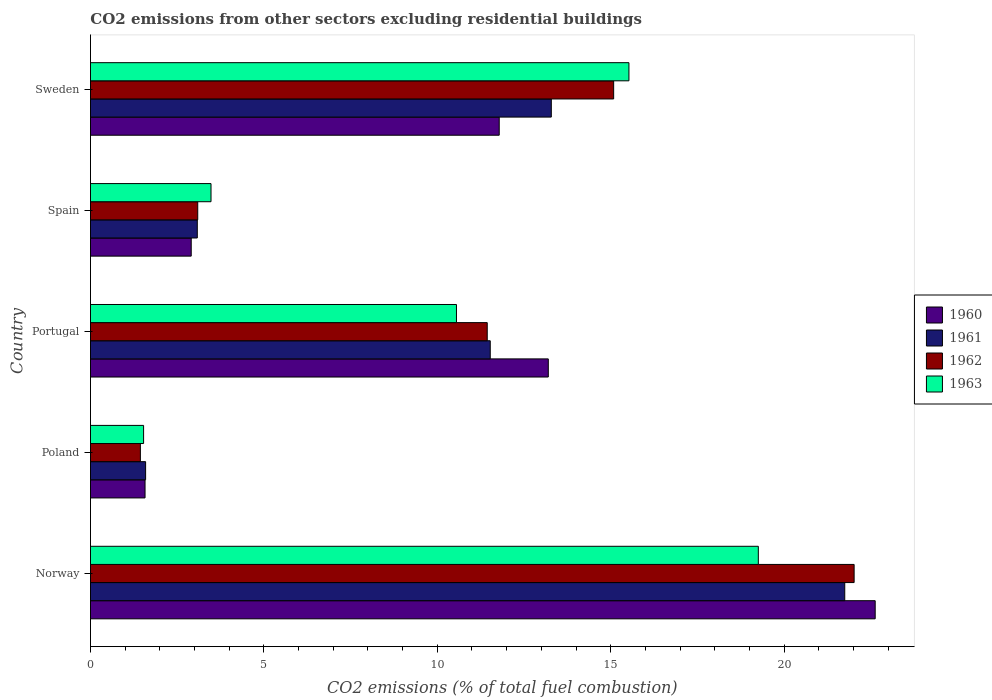How many different coloured bars are there?
Ensure brevity in your answer.  4. Are the number of bars per tick equal to the number of legend labels?
Provide a short and direct response. Yes. How many bars are there on the 5th tick from the top?
Give a very brief answer. 4. What is the label of the 2nd group of bars from the top?
Your answer should be compact. Spain. In how many cases, is the number of bars for a given country not equal to the number of legend labels?
Give a very brief answer. 0. What is the total CO2 emitted in 1962 in Poland?
Your answer should be compact. 1.44. Across all countries, what is the maximum total CO2 emitted in 1963?
Ensure brevity in your answer.  19.26. Across all countries, what is the minimum total CO2 emitted in 1963?
Provide a short and direct response. 1.53. What is the total total CO2 emitted in 1962 in the graph?
Give a very brief answer. 53.08. What is the difference between the total CO2 emitted in 1962 in Spain and that in Sweden?
Give a very brief answer. -11.99. What is the difference between the total CO2 emitted in 1962 in Poland and the total CO2 emitted in 1960 in Spain?
Keep it short and to the point. -1.47. What is the average total CO2 emitted in 1962 per country?
Your response must be concise. 10.62. What is the difference between the total CO2 emitted in 1961 and total CO2 emitted in 1963 in Sweden?
Offer a terse response. -2.24. In how many countries, is the total CO2 emitted in 1960 greater than 7 ?
Give a very brief answer. 3. What is the ratio of the total CO2 emitted in 1960 in Poland to that in Sweden?
Make the answer very short. 0.13. What is the difference between the highest and the second highest total CO2 emitted in 1960?
Provide a succinct answer. 9.43. What is the difference between the highest and the lowest total CO2 emitted in 1961?
Keep it short and to the point. 20.16. In how many countries, is the total CO2 emitted in 1963 greater than the average total CO2 emitted in 1963 taken over all countries?
Ensure brevity in your answer.  3. What does the 2nd bar from the top in Poland represents?
Give a very brief answer. 1962. What does the 2nd bar from the bottom in Norway represents?
Keep it short and to the point. 1961. Is it the case that in every country, the sum of the total CO2 emitted in 1963 and total CO2 emitted in 1960 is greater than the total CO2 emitted in 1962?
Provide a short and direct response. Yes. Are all the bars in the graph horizontal?
Make the answer very short. Yes. What is the difference between two consecutive major ticks on the X-axis?
Offer a very short reply. 5. Does the graph contain grids?
Give a very brief answer. No. How are the legend labels stacked?
Your answer should be compact. Vertical. What is the title of the graph?
Offer a very short reply. CO2 emissions from other sectors excluding residential buildings. Does "1992" appear as one of the legend labels in the graph?
Offer a very short reply. No. What is the label or title of the X-axis?
Offer a terse response. CO2 emissions (% of total fuel combustion). What is the label or title of the Y-axis?
Your response must be concise. Country. What is the CO2 emissions (% of total fuel combustion) in 1960 in Norway?
Offer a terse response. 22.63. What is the CO2 emissions (% of total fuel combustion) in 1961 in Norway?
Make the answer very short. 21.75. What is the CO2 emissions (% of total fuel combustion) in 1962 in Norway?
Provide a short and direct response. 22.02. What is the CO2 emissions (% of total fuel combustion) in 1963 in Norway?
Keep it short and to the point. 19.26. What is the CO2 emissions (% of total fuel combustion) of 1960 in Poland?
Provide a short and direct response. 1.57. What is the CO2 emissions (% of total fuel combustion) of 1961 in Poland?
Make the answer very short. 1.59. What is the CO2 emissions (% of total fuel combustion) in 1962 in Poland?
Provide a succinct answer. 1.44. What is the CO2 emissions (% of total fuel combustion) in 1963 in Poland?
Keep it short and to the point. 1.53. What is the CO2 emissions (% of total fuel combustion) in 1960 in Portugal?
Offer a very short reply. 13.2. What is the CO2 emissions (% of total fuel combustion) in 1961 in Portugal?
Your response must be concise. 11.53. What is the CO2 emissions (% of total fuel combustion) of 1962 in Portugal?
Offer a terse response. 11.44. What is the CO2 emissions (% of total fuel combustion) of 1963 in Portugal?
Give a very brief answer. 10.55. What is the CO2 emissions (% of total fuel combustion) of 1960 in Spain?
Keep it short and to the point. 2.91. What is the CO2 emissions (% of total fuel combustion) of 1961 in Spain?
Provide a short and direct response. 3.08. What is the CO2 emissions (% of total fuel combustion) of 1962 in Spain?
Your answer should be compact. 3.09. What is the CO2 emissions (% of total fuel combustion) of 1963 in Spain?
Give a very brief answer. 3.48. What is the CO2 emissions (% of total fuel combustion) of 1960 in Sweden?
Offer a very short reply. 11.79. What is the CO2 emissions (% of total fuel combustion) of 1961 in Sweden?
Make the answer very short. 13.29. What is the CO2 emissions (% of total fuel combustion) in 1962 in Sweden?
Make the answer very short. 15.09. What is the CO2 emissions (% of total fuel combustion) of 1963 in Sweden?
Provide a succinct answer. 15.53. Across all countries, what is the maximum CO2 emissions (% of total fuel combustion) in 1960?
Provide a succinct answer. 22.63. Across all countries, what is the maximum CO2 emissions (% of total fuel combustion) in 1961?
Provide a short and direct response. 21.75. Across all countries, what is the maximum CO2 emissions (% of total fuel combustion) of 1962?
Your answer should be very brief. 22.02. Across all countries, what is the maximum CO2 emissions (% of total fuel combustion) of 1963?
Provide a succinct answer. 19.26. Across all countries, what is the minimum CO2 emissions (% of total fuel combustion) in 1960?
Your response must be concise. 1.57. Across all countries, what is the minimum CO2 emissions (% of total fuel combustion) of 1961?
Keep it short and to the point. 1.59. Across all countries, what is the minimum CO2 emissions (% of total fuel combustion) in 1962?
Ensure brevity in your answer.  1.44. Across all countries, what is the minimum CO2 emissions (% of total fuel combustion) of 1963?
Give a very brief answer. 1.53. What is the total CO2 emissions (% of total fuel combustion) in 1960 in the graph?
Keep it short and to the point. 52.09. What is the total CO2 emissions (% of total fuel combustion) of 1961 in the graph?
Your response must be concise. 51.24. What is the total CO2 emissions (% of total fuel combustion) of 1962 in the graph?
Provide a succinct answer. 53.08. What is the total CO2 emissions (% of total fuel combustion) in 1963 in the graph?
Keep it short and to the point. 50.34. What is the difference between the CO2 emissions (% of total fuel combustion) in 1960 in Norway and that in Poland?
Offer a terse response. 21.05. What is the difference between the CO2 emissions (% of total fuel combustion) of 1961 in Norway and that in Poland?
Offer a very short reply. 20.16. What is the difference between the CO2 emissions (% of total fuel combustion) of 1962 in Norway and that in Poland?
Provide a short and direct response. 20.58. What is the difference between the CO2 emissions (% of total fuel combustion) in 1963 in Norway and that in Poland?
Make the answer very short. 17.73. What is the difference between the CO2 emissions (% of total fuel combustion) of 1960 in Norway and that in Portugal?
Provide a short and direct response. 9.43. What is the difference between the CO2 emissions (% of total fuel combustion) in 1961 in Norway and that in Portugal?
Provide a succinct answer. 10.22. What is the difference between the CO2 emissions (% of total fuel combustion) of 1962 in Norway and that in Portugal?
Offer a very short reply. 10.58. What is the difference between the CO2 emissions (% of total fuel combustion) in 1963 in Norway and that in Portugal?
Ensure brevity in your answer.  8.7. What is the difference between the CO2 emissions (% of total fuel combustion) of 1960 in Norway and that in Spain?
Keep it short and to the point. 19.72. What is the difference between the CO2 emissions (% of total fuel combustion) in 1961 in Norway and that in Spain?
Ensure brevity in your answer.  18.67. What is the difference between the CO2 emissions (% of total fuel combustion) of 1962 in Norway and that in Spain?
Ensure brevity in your answer.  18.93. What is the difference between the CO2 emissions (% of total fuel combustion) of 1963 in Norway and that in Spain?
Offer a very short reply. 15.78. What is the difference between the CO2 emissions (% of total fuel combustion) in 1960 in Norway and that in Sweden?
Your answer should be very brief. 10.84. What is the difference between the CO2 emissions (% of total fuel combustion) in 1961 in Norway and that in Sweden?
Make the answer very short. 8.46. What is the difference between the CO2 emissions (% of total fuel combustion) in 1962 in Norway and that in Sweden?
Ensure brevity in your answer.  6.93. What is the difference between the CO2 emissions (% of total fuel combustion) in 1963 in Norway and that in Sweden?
Provide a succinct answer. 3.73. What is the difference between the CO2 emissions (% of total fuel combustion) in 1960 in Poland and that in Portugal?
Offer a very short reply. -11.63. What is the difference between the CO2 emissions (% of total fuel combustion) in 1961 in Poland and that in Portugal?
Provide a succinct answer. -9.94. What is the difference between the CO2 emissions (% of total fuel combustion) of 1962 in Poland and that in Portugal?
Your answer should be very brief. -10. What is the difference between the CO2 emissions (% of total fuel combustion) of 1963 in Poland and that in Portugal?
Give a very brief answer. -9.02. What is the difference between the CO2 emissions (% of total fuel combustion) of 1960 in Poland and that in Spain?
Make the answer very short. -1.33. What is the difference between the CO2 emissions (% of total fuel combustion) in 1961 in Poland and that in Spain?
Offer a very short reply. -1.49. What is the difference between the CO2 emissions (% of total fuel combustion) of 1962 in Poland and that in Spain?
Ensure brevity in your answer.  -1.65. What is the difference between the CO2 emissions (% of total fuel combustion) in 1963 in Poland and that in Spain?
Your answer should be very brief. -1.94. What is the difference between the CO2 emissions (% of total fuel combustion) in 1960 in Poland and that in Sweden?
Provide a succinct answer. -10.21. What is the difference between the CO2 emissions (% of total fuel combustion) of 1961 in Poland and that in Sweden?
Give a very brief answer. -11.7. What is the difference between the CO2 emissions (% of total fuel combustion) of 1962 in Poland and that in Sweden?
Provide a succinct answer. -13.65. What is the difference between the CO2 emissions (% of total fuel combustion) of 1963 in Poland and that in Sweden?
Ensure brevity in your answer.  -13.99. What is the difference between the CO2 emissions (% of total fuel combustion) of 1960 in Portugal and that in Spain?
Provide a short and direct response. 10.3. What is the difference between the CO2 emissions (% of total fuel combustion) of 1961 in Portugal and that in Spain?
Provide a short and direct response. 8.45. What is the difference between the CO2 emissions (% of total fuel combustion) of 1962 in Portugal and that in Spain?
Keep it short and to the point. 8.35. What is the difference between the CO2 emissions (% of total fuel combustion) in 1963 in Portugal and that in Spain?
Ensure brevity in your answer.  7.08. What is the difference between the CO2 emissions (% of total fuel combustion) in 1960 in Portugal and that in Sweden?
Your response must be concise. 1.42. What is the difference between the CO2 emissions (% of total fuel combustion) of 1961 in Portugal and that in Sweden?
Offer a terse response. -1.76. What is the difference between the CO2 emissions (% of total fuel combustion) of 1962 in Portugal and that in Sweden?
Make the answer very short. -3.65. What is the difference between the CO2 emissions (% of total fuel combustion) in 1963 in Portugal and that in Sweden?
Your answer should be very brief. -4.97. What is the difference between the CO2 emissions (% of total fuel combustion) of 1960 in Spain and that in Sweden?
Your answer should be very brief. -8.88. What is the difference between the CO2 emissions (% of total fuel combustion) of 1961 in Spain and that in Sweden?
Give a very brief answer. -10.21. What is the difference between the CO2 emissions (% of total fuel combustion) of 1962 in Spain and that in Sweden?
Make the answer very short. -11.99. What is the difference between the CO2 emissions (% of total fuel combustion) of 1963 in Spain and that in Sweden?
Give a very brief answer. -12.05. What is the difference between the CO2 emissions (% of total fuel combustion) in 1960 in Norway and the CO2 emissions (% of total fuel combustion) in 1961 in Poland?
Keep it short and to the point. 21.04. What is the difference between the CO2 emissions (% of total fuel combustion) in 1960 in Norway and the CO2 emissions (% of total fuel combustion) in 1962 in Poland?
Keep it short and to the point. 21.19. What is the difference between the CO2 emissions (% of total fuel combustion) in 1960 in Norway and the CO2 emissions (% of total fuel combustion) in 1963 in Poland?
Keep it short and to the point. 21.1. What is the difference between the CO2 emissions (% of total fuel combustion) of 1961 in Norway and the CO2 emissions (% of total fuel combustion) of 1962 in Poland?
Keep it short and to the point. 20.31. What is the difference between the CO2 emissions (% of total fuel combustion) of 1961 in Norway and the CO2 emissions (% of total fuel combustion) of 1963 in Poland?
Your answer should be very brief. 20.22. What is the difference between the CO2 emissions (% of total fuel combustion) of 1962 in Norway and the CO2 emissions (% of total fuel combustion) of 1963 in Poland?
Your response must be concise. 20.49. What is the difference between the CO2 emissions (% of total fuel combustion) in 1960 in Norway and the CO2 emissions (% of total fuel combustion) in 1961 in Portugal?
Ensure brevity in your answer.  11.1. What is the difference between the CO2 emissions (% of total fuel combustion) of 1960 in Norway and the CO2 emissions (% of total fuel combustion) of 1962 in Portugal?
Provide a succinct answer. 11.19. What is the difference between the CO2 emissions (% of total fuel combustion) of 1960 in Norway and the CO2 emissions (% of total fuel combustion) of 1963 in Portugal?
Your answer should be compact. 12.07. What is the difference between the CO2 emissions (% of total fuel combustion) in 1961 in Norway and the CO2 emissions (% of total fuel combustion) in 1962 in Portugal?
Offer a terse response. 10.31. What is the difference between the CO2 emissions (% of total fuel combustion) of 1961 in Norway and the CO2 emissions (% of total fuel combustion) of 1963 in Portugal?
Give a very brief answer. 11.2. What is the difference between the CO2 emissions (% of total fuel combustion) of 1962 in Norway and the CO2 emissions (% of total fuel combustion) of 1963 in Portugal?
Give a very brief answer. 11.47. What is the difference between the CO2 emissions (% of total fuel combustion) in 1960 in Norway and the CO2 emissions (% of total fuel combustion) in 1961 in Spain?
Your answer should be very brief. 19.55. What is the difference between the CO2 emissions (% of total fuel combustion) of 1960 in Norway and the CO2 emissions (% of total fuel combustion) of 1962 in Spain?
Make the answer very short. 19.53. What is the difference between the CO2 emissions (% of total fuel combustion) in 1960 in Norway and the CO2 emissions (% of total fuel combustion) in 1963 in Spain?
Ensure brevity in your answer.  19.15. What is the difference between the CO2 emissions (% of total fuel combustion) in 1961 in Norway and the CO2 emissions (% of total fuel combustion) in 1962 in Spain?
Give a very brief answer. 18.66. What is the difference between the CO2 emissions (% of total fuel combustion) in 1961 in Norway and the CO2 emissions (% of total fuel combustion) in 1963 in Spain?
Your answer should be very brief. 18.27. What is the difference between the CO2 emissions (% of total fuel combustion) of 1962 in Norway and the CO2 emissions (% of total fuel combustion) of 1963 in Spain?
Keep it short and to the point. 18.54. What is the difference between the CO2 emissions (% of total fuel combustion) of 1960 in Norway and the CO2 emissions (% of total fuel combustion) of 1961 in Sweden?
Offer a very short reply. 9.34. What is the difference between the CO2 emissions (% of total fuel combustion) of 1960 in Norway and the CO2 emissions (% of total fuel combustion) of 1962 in Sweden?
Keep it short and to the point. 7.54. What is the difference between the CO2 emissions (% of total fuel combustion) in 1960 in Norway and the CO2 emissions (% of total fuel combustion) in 1963 in Sweden?
Your answer should be compact. 7.1. What is the difference between the CO2 emissions (% of total fuel combustion) of 1961 in Norway and the CO2 emissions (% of total fuel combustion) of 1962 in Sweden?
Keep it short and to the point. 6.66. What is the difference between the CO2 emissions (% of total fuel combustion) of 1961 in Norway and the CO2 emissions (% of total fuel combustion) of 1963 in Sweden?
Your answer should be compact. 6.22. What is the difference between the CO2 emissions (% of total fuel combustion) in 1962 in Norway and the CO2 emissions (% of total fuel combustion) in 1963 in Sweden?
Keep it short and to the point. 6.49. What is the difference between the CO2 emissions (% of total fuel combustion) of 1960 in Poland and the CO2 emissions (% of total fuel combustion) of 1961 in Portugal?
Provide a succinct answer. -9.95. What is the difference between the CO2 emissions (% of total fuel combustion) in 1960 in Poland and the CO2 emissions (% of total fuel combustion) in 1962 in Portugal?
Provide a succinct answer. -9.87. What is the difference between the CO2 emissions (% of total fuel combustion) of 1960 in Poland and the CO2 emissions (% of total fuel combustion) of 1963 in Portugal?
Your answer should be very brief. -8.98. What is the difference between the CO2 emissions (% of total fuel combustion) of 1961 in Poland and the CO2 emissions (% of total fuel combustion) of 1962 in Portugal?
Ensure brevity in your answer.  -9.85. What is the difference between the CO2 emissions (% of total fuel combustion) in 1961 in Poland and the CO2 emissions (% of total fuel combustion) in 1963 in Portugal?
Your answer should be very brief. -8.96. What is the difference between the CO2 emissions (% of total fuel combustion) of 1962 in Poland and the CO2 emissions (% of total fuel combustion) of 1963 in Portugal?
Keep it short and to the point. -9.11. What is the difference between the CO2 emissions (% of total fuel combustion) in 1960 in Poland and the CO2 emissions (% of total fuel combustion) in 1961 in Spain?
Give a very brief answer. -1.51. What is the difference between the CO2 emissions (% of total fuel combustion) in 1960 in Poland and the CO2 emissions (% of total fuel combustion) in 1962 in Spain?
Your answer should be compact. -1.52. What is the difference between the CO2 emissions (% of total fuel combustion) of 1960 in Poland and the CO2 emissions (% of total fuel combustion) of 1963 in Spain?
Provide a short and direct response. -1.9. What is the difference between the CO2 emissions (% of total fuel combustion) in 1961 in Poland and the CO2 emissions (% of total fuel combustion) in 1962 in Spain?
Ensure brevity in your answer.  -1.5. What is the difference between the CO2 emissions (% of total fuel combustion) in 1961 in Poland and the CO2 emissions (% of total fuel combustion) in 1963 in Spain?
Your answer should be very brief. -1.89. What is the difference between the CO2 emissions (% of total fuel combustion) in 1962 in Poland and the CO2 emissions (% of total fuel combustion) in 1963 in Spain?
Provide a short and direct response. -2.04. What is the difference between the CO2 emissions (% of total fuel combustion) in 1960 in Poland and the CO2 emissions (% of total fuel combustion) in 1961 in Sweden?
Provide a short and direct response. -11.71. What is the difference between the CO2 emissions (% of total fuel combustion) of 1960 in Poland and the CO2 emissions (% of total fuel combustion) of 1962 in Sweden?
Offer a very short reply. -13.51. What is the difference between the CO2 emissions (% of total fuel combustion) in 1960 in Poland and the CO2 emissions (% of total fuel combustion) in 1963 in Sweden?
Your answer should be compact. -13.95. What is the difference between the CO2 emissions (% of total fuel combustion) in 1961 in Poland and the CO2 emissions (% of total fuel combustion) in 1962 in Sweden?
Provide a succinct answer. -13.5. What is the difference between the CO2 emissions (% of total fuel combustion) of 1961 in Poland and the CO2 emissions (% of total fuel combustion) of 1963 in Sweden?
Give a very brief answer. -13.94. What is the difference between the CO2 emissions (% of total fuel combustion) in 1962 in Poland and the CO2 emissions (% of total fuel combustion) in 1963 in Sweden?
Make the answer very short. -14.09. What is the difference between the CO2 emissions (% of total fuel combustion) of 1960 in Portugal and the CO2 emissions (% of total fuel combustion) of 1961 in Spain?
Provide a succinct answer. 10.12. What is the difference between the CO2 emissions (% of total fuel combustion) in 1960 in Portugal and the CO2 emissions (% of total fuel combustion) in 1962 in Spain?
Offer a terse response. 10.11. What is the difference between the CO2 emissions (% of total fuel combustion) in 1960 in Portugal and the CO2 emissions (% of total fuel combustion) in 1963 in Spain?
Provide a short and direct response. 9.73. What is the difference between the CO2 emissions (% of total fuel combustion) in 1961 in Portugal and the CO2 emissions (% of total fuel combustion) in 1962 in Spain?
Provide a short and direct response. 8.43. What is the difference between the CO2 emissions (% of total fuel combustion) of 1961 in Portugal and the CO2 emissions (% of total fuel combustion) of 1963 in Spain?
Give a very brief answer. 8.05. What is the difference between the CO2 emissions (% of total fuel combustion) in 1962 in Portugal and the CO2 emissions (% of total fuel combustion) in 1963 in Spain?
Your answer should be compact. 7.96. What is the difference between the CO2 emissions (% of total fuel combustion) of 1960 in Portugal and the CO2 emissions (% of total fuel combustion) of 1961 in Sweden?
Keep it short and to the point. -0.09. What is the difference between the CO2 emissions (% of total fuel combustion) of 1960 in Portugal and the CO2 emissions (% of total fuel combustion) of 1962 in Sweden?
Keep it short and to the point. -1.88. What is the difference between the CO2 emissions (% of total fuel combustion) in 1960 in Portugal and the CO2 emissions (% of total fuel combustion) in 1963 in Sweden?
Provide a short and direct response. -2.33. What is the difference between the CO2 emissions (% of total fuel combustion) in 1961 in Portugal and the CO2 emissions (% of total fuel combustion) in 1962 in Sweden?
Provide a short and direct response. -3.56. What is the difference between the CO2 emissions (% of total fuel combustion) of 1961 in Portugal and the CO2 emissions (% of total fuel combustion) of 1963 in Sweden?
Your answer should be very brief. -4. What is the difference between the CO2 emissions (% of total fuel combustion) in 1962 in Portugal and the CO2 emissions (% of total fuel combustion) in 1963 in Sweden?
Ensure brevity in your answer.  -4.09. What is the difference between the CO2 emissions (% of total fuel combustion) in 1960 in Spain and the CO2 emissions (% of total fuel combustion) in 1961 in Sweden?
Your response must be concise. -10.38. What is the difference between the CO2 emissions (% of total fuel combustion) in 1960 in Spain and the CO2 emissions (% of total fuel combustion) in 1962 in Sweden?
Ensure brevity in your answer.  -12.18. What is the difference between the CO2 emissions (% of total fuel combustion) of 1960 in Spain and the CO2 emissions (% of total fuel combustion) of 1963 in Sweden?
Provide a succinct answer. -12.62. What is the difference between the CO2 emissions (% of total fuel combustion) in 1961 in Spain and the CO2 emissions (% of total fuel combustion) in 1962 in Sweden?
Your response must be concise. -12.01. What is the difference between the CO2 emissions (% of total fuel combustion) in 1961 in Spain and the CO2 emissions (% of total fuel combustion) in 1963 in Sweden?
Keep it short and to the point. -12.45. What is the difference between the CO2 emissions (% of total fuel combustion) of 1962 in Spain and the CO2 emissions (% of total fuel combustion) of 1963 in Sweden?
Your answer should be compact. -12.43. What is the average CO2 emissions (% of total fuel combustion) in 1960 per country?
Provide a succinct answer. 10.42. What is the average CO2 emissions (% of total fuel combustion) of 1961 per country?
Make the answer very short. 10.25. What is the average CO2 emissions (% of total fuel combustion) of 1962 per country?
Give a very brief answer. 10.62. What is the average CO2 emissions (% of total fuel combustion) of 1963 per country?
Ensure brevity in your answer.  10.07. What is the difference between the CO2 emissions (% of total fuel combustion) in 1960 and CO2 emissions (% of total fuel combustion) in 1961 in Norway?
Your response must be concise. 0.88. What is the difference between the CO2 emissions (% of total fuel combustion) of 1960 and CO2 emissions (% of total fuel combustion) of 1962 in Norway?
Offer a terse response. 0.61. What is the difference between the CO2 emissions (% of total fuel combustion) in 1960 and CO2 emissions (% of total fuel combustion) in 1963 in Norway?
Offer a very short reply. 3.37. What is the difference between the CO2 emissions (% of total fuel combustion) in 1961 and CO2 emissions (% of total fuel combustion) in 1962 in Norway?
Your answer should be very brief. -0.27. What is the difference between the CO2 emissions (% of total fuel combustion) in 1961 and CO2 emissions (% of total fuel combustion) in 1963 in Norway?
Offer a terse response. 2.49. What is the difference between the CO2 emissions (% of total fuel combustion) in 1962 and CO2 emissions (% of total fuel combustion) in 1963 in Norway?
Provide a succinct answer. 2.76. What is the difference between the CO2 emissions (% of total fuel combustion) of 1960 and CO2 emissions (% of total fuel combustion) of 1961 in Poland?
Your answer should be compact. -0.02. What is the difference between the CO2 emissions (% of total fuel combustion) of 1960 and CO2 emissions (% of total fuel combustion) of 1962 in Poland?
Your answer should be compact. 0.13. What is the difference between the CO2 emissions (% of total fuel combustion) of 1960 and CO2 emissions (% of total fuel combustion) of 1963 in Poland?
Offer a very short reply. 0.04. What is the difference between the CO2 emissions (% of total fuel combustion) of 1961 and CO2 emissions (% of total fuel combustion) of 1962 in Poland?
Ensure brevity in your answer.  0.15. What is the difference between the CO2 emissions (% of total fuel combustion) in 1961 and CO2 emissions (% of total fuel combustion) in 1963 in Poland?
Ensure brevity in your answer.  0.06. What is the difference between the CO2 emissions (% of total fuel combustion) of 1962 and CO2 emissions (% of total fuel combustion) of 1963 in Poland?
Your response must be concise. -0.09. What is the difference between the CO2 emissions (% of total fuel combustion) of 1960 and CO2 emissions (% of total fuel combustion) of 1961 in Portugal?
Make the answer very short. 1.67. What is the difference between the CO2 emissions (% of total fuel combustion) in 1960 and CO2 emissions (% of total fuel combustion) in 1962 in Portugal?
Keep it short and to the point. 1.76. What is the difference between the CO2 emissions (% of total fuel combustion) in 1960 and CO2 emissions (% of total fuel combustion) in 1963 in Portugal?
Your response must be concise. 2.65. What is the difference between the CO2 emissions (% of total fuel combustion) of 1961 and CO2 emissions (% of total fuel combustion) of 1962 in Portugal?
Provide a succinct answer. 0.09. What is the difference between the CO2 emissions (% of total fuel combustion) in 1962 and CO2 emissions (% of total fuel combustion) in 1963 in Portugal?
Your answer should be compact. 0.89. What is the difference between the CO2 emissions (% of total fuel combustion) of 1960 and CO2 emissions (% of total fuel combustion) of 1961 in Spain?
Your answer should be very brief. -0.17. What is the difference between the CO2 emissions (% of total fuel combustion) in 1960 and CO2 emissions (% of total fuel combustion) in 1962 in Spain?
Your response must be concise. -0.19. What is the difference between the CO2 emissions (% of total fuel combustion) in 1960 and CO2 emissions (% of total fuel combustion) in 1963 in Spain?
Your answer should be compact. -0.57. What is the difference between the CO2 emissions (% of total fuel combustion) of 1961 and CO2 emissions (% of total fuel combustion) of 1962 in Spain?
Offer a very short reply. -0.01. What is the difference between the CO2 emissions (% of total fuel combustion) of 1961 and CO2 emissions (% of total fuel combustion) of 1963 in Spain?
Give a very brief answer. -0.4. What is the difference between the CO2 emissions (% of total fuel combustion) in 1962 and CO2 emissions (% of total fuel combustion) in 1963 in Spain?
Give a very brief answer. -0.38. What is the difference between the CO2 emissions (% of total fuel combustion) in 1960 and CO2 emissions (% of total fuel combustion) in 1961 in Sweden?
Your response must be concise. -1.5. What is the difference between the CO2 emissions (% of total fuel combustion) in 1960 and CO2 emissions (% of total fuel combustion) in 1962 in Sweden?
Offer a terse response. -3.3. What is the difference between the CO2 emissions (% of total fuel combustion) in 1960 and CO2 emissions (% of total fuel combustion) in 1963 in Sweden?
Offer a terse response. -3.74. What is the difference between the CO2 emissions (% of total fuel combustion) of 1961 and CO2 emissions (% of total fuel combustion) of 1962 in Sweden?
Offer a very short reply. -1.8. What is the difference between the CO2 emissions (% of total fuel combustion) in 1961 and CO2 emissions (% of total fuel combustion) in 1963 in Sweden?
Your answer should be compact. -2.24. What is the difference between the CO2 emissions (% of total fuel combustion) of 1962 and CO2 emissions (% of total fuel combustion) of 1963 in Sweden?
Make the answer very short. -0.44. What is the ratio of the CO2 emissions (% of total fuel combustion) in 1960 in Norway to that in Poland?
Your answer should be very brief. 14.38. What is the ratio of the CO2 emissions (% of total fuel combustion) of 1961 in Norway to that in Poland?
Ensure brevity in your answer.  13.68. What is the ratio of the CO2 emissions (% of total fuel combustion) of 1962 in Norway to that in Poland?
Make the answer very short. 15.3. What is the ratio of the CO2 emissions (% of total fuel combustion) in 1963 in Norway to that in Poland?
Your answer should be compact. 12.57. What is the ratio of the CO2 emissions (% of total fuel combustion) in 1960 in Norway to that in Portugal?
Give a very brief answer. 1.71. What is the ratio of the CO2 emissions (% of total fuel combustion) of 1961 in Norway to that in Portugal?
Provide a short and direct response. 1.89. What is the ratio of the CO2 emissions (% of total fuel combustion) of 1962 in Norway to that in Portugal?
Your response must be concise. 1.92. What is the ratio of the CO2 emissions (% of total fuel combustion) in 1963 in Norway to that in Portugal?
Your answer should be very brief. 1.82. What is the ratio of the CO2 emissions (% of total fuel combustion) of 1960 in Norway to that in Spain?
Ensure brevity in your answer.  7.79. What is the ratio of the CO2 emissions (% of total fuel combustion) in 1961 in Norway to that in Spain?
Give a very brief answer. 7.06. What is the ratio of the CO2 emissions (% of total fuel combustion) of 1962 in Norway to that in Spain?
Your answer should be very brief. 7.12. What is the ratio of the CO2 emissions (% of total fuel combustion) of 1963 in Norway to that in Spain?
Offer a terse response. 5.54. What is the ratio of the CO2 emissions (% of total fuel combustion) of 1960 in Norway to that in Sweden?
Keep it short and to the point. 1.92. What is the ratio of the CO2 emissions (% of total fuel combustion) in 1961 in Norway to that in Sweden?
Ensure brevity in your answer.  1.64. What is the ratio of the CO2 emissions (% of total fuel combustion) in 1962 in Norway to that in Sweden?
Ensure brevity in your answer.  1.46. What is the ratio of the CO2 emissions (% of total fuel combustion) of 1963 in Norway to that in Sweden?
Make the answer very short. 1.24. What is the ratio of the CO2 emissions (% of total fuel combustion) in 1960 in Poland to that in Portugal?
Offer a terse response. 0.12. What is the ratio of the CO2 emissions (% of total fuel combustion) in 1961 in Poland to that in Portugal?
Give a very brief answer. 0.14. What is the ratio of the CO2 emissions (% of total fuel combustion) in 1962 in Poland to that in Portugal?
Your response must be concise. 0.13. What is the ratio of the CO2 emissions (% of total fuel combustion) of 1963 in Poland to that in Portugal?
Offer a terse response. 0.15. What is the ratio of the CO2 emissions (% of total fuel combustion) of 1960 in Poland to that in Spain?
Your answer should be compact. 0.54. What is the ratio of the CO2 emissions (% of total fuel combustion) of 1961 in Poland to that in Spain?
Offer a very short reply. 0.52. What is the ratio of the CO2 emissions (% of total fuel combustion) in 1962 in Poland to that in Spain?
Keep it short and to the point. 0.47. What is the ratio of the CO2 emissions (% of total fuel combustion) of 1963 in Poland to that in Spain?
Give a very brief answer. 0.44. What is the ratio of the CO2 emissions (% of total fuel combustion) of 1960 in Poland to that in Sweden?
Your response must be concise. 0.13. What is the ratio of the CO2 emissions (% of total fuel combustion) in 1961 in Poland to that in Sweden?
Give a very brief answer. 0.12. What is the ratio of the CO2 emissions (% of total fuel combustion) in 1962 in Poland to that in Sweden?
Ensure brevity in your answer.  0.1. What is the ratio of the CO2 emissions (% of total fuel combustion) in 1963 in Poland to that in Sweden?
Give a very brief answer. 0.1. What is the ratio of the CO2 emissions (% of total fuel combustion) in 1960 in Portugal to that in Spain?
Give a very brief answer. 4.54. What is the ratio of the CO2 emissions (% of total fuel combustion) in 1961 in Portugal to that in Spain?
Your answer should be very brief. 3.74. What is the ratio of the CO2 emissions (% of total fuel combustion) in 1962 in Portugal to that in Spain?
Your answer should be very brief. 3.7. What is the ratio of the CO2 emissions (% of total fuel combustion) in 1963 in Portugal to that in Spain?
Offer a terse response. 3.04. What is the ratio of the CO2 emissions (% of total fuel combustion) of 1960 in Portugal to that in Sweden?
Keep it short and to the point. 1.12. What is the ratio of the CO2 emissions (% of total fuel combustion) in 1961 in Portugal to that in Sweden?
Give a very brief answer. 0.87. What is the ratio of the CO2 emissions (% of total fuel combustion) in 1962 in Portugal to that in Sweden?
Ensure brevity in your answer.  0.76. What is the ratio of the CO2 emissions (% of total fuel combustion) in 1963 in Portugal to that in Sweden?
Offer a very short reply. 0.68. What is the ratio of the CO2 emissions (% of total fuel combustion) in 1960 in Spain to that in Sweden?
Give a very brief answer. 0.25. What is the ratio of the CO2 emissions (% of total fuel combustion) in 1961 in Spain to that in Sweden?
Ensure brevity in your answer.  0.23. What is the ratio of the CO2 emissions (% of total fuel combustion) in 1962 in Spain to that in Sweden?
Ensure brevity in your answer.  0.2. What is the ratio of the CO2 emissions (% of total fuel combustion) of 1963 in Spain to that in Sweden?
Ensure brevity in your answer.  0.22. What is the difference between the highest and the second highest CO2 emissions (% of total fuel combustion) of 1960?
Give a very brief answer. 9.43. What is the difference between the highest and the second highest CO2 emissions (% of total fuel combustion) in 1961?
Provide a short and direct response. 8.46. What is the difference between the highest and the second highest CO2 emissions (% of total fuel combustion) in 1962?
Your response must be concise. 6.93. What is the difference between the highest and the second highest CO2 emissions (% of total fuel combustion) of 1963?
Ensure brevity in your answer.  3.73. What is the difference between the highest and the lowest CO2 emissions (% of total fuel combustion) of 1960?
Your response must be concise. 21.05. What is the difference between the highest and the lowest CO2 emissions (% of total fuel combustion) in 1961?
Offer a very short reply. 20.16. What is the difference between the highest and the lowest CO2 emissions (% of total fuel combustion) in 1962?
Give a very brief answer. 20.58. What is the difference between the highest and the lowest CO2 emissions (% of total fuel combustion) of 1963?
Make the answer very short. 17.73. 